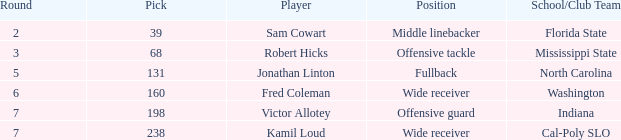Which school/club team has a pick number of 198? Indiana. 